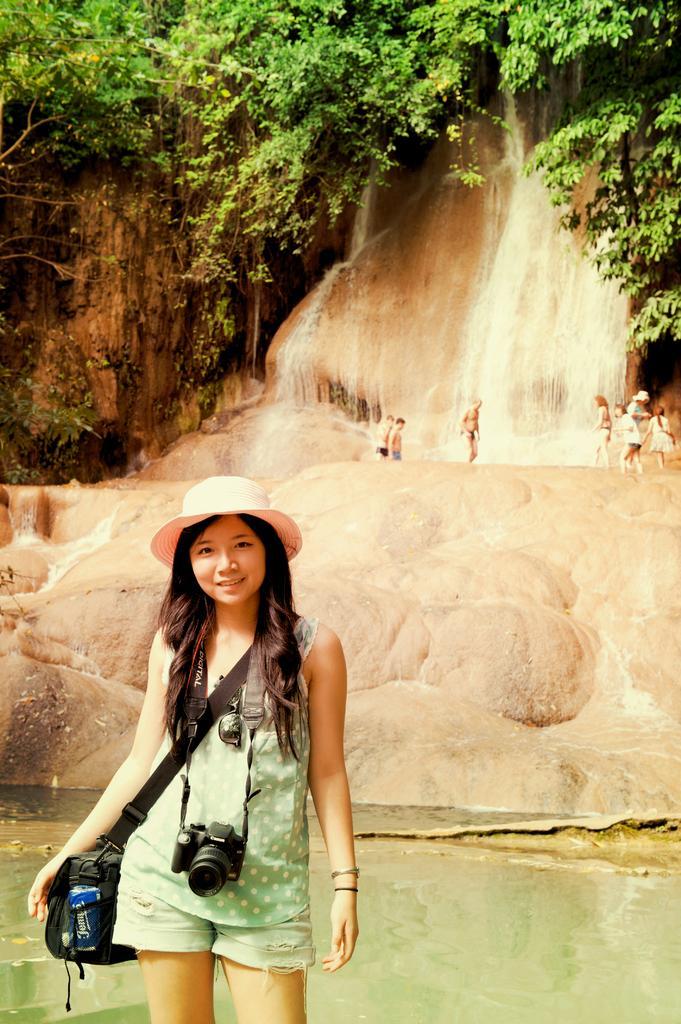Please provide a concise description of this image. Here I can see a woman wearing a bag and a camera, standing, smiling and giving pose for the picture. At the back of her, I can see the water. In the background there are few rocks. At the top of the image there are some trees. 